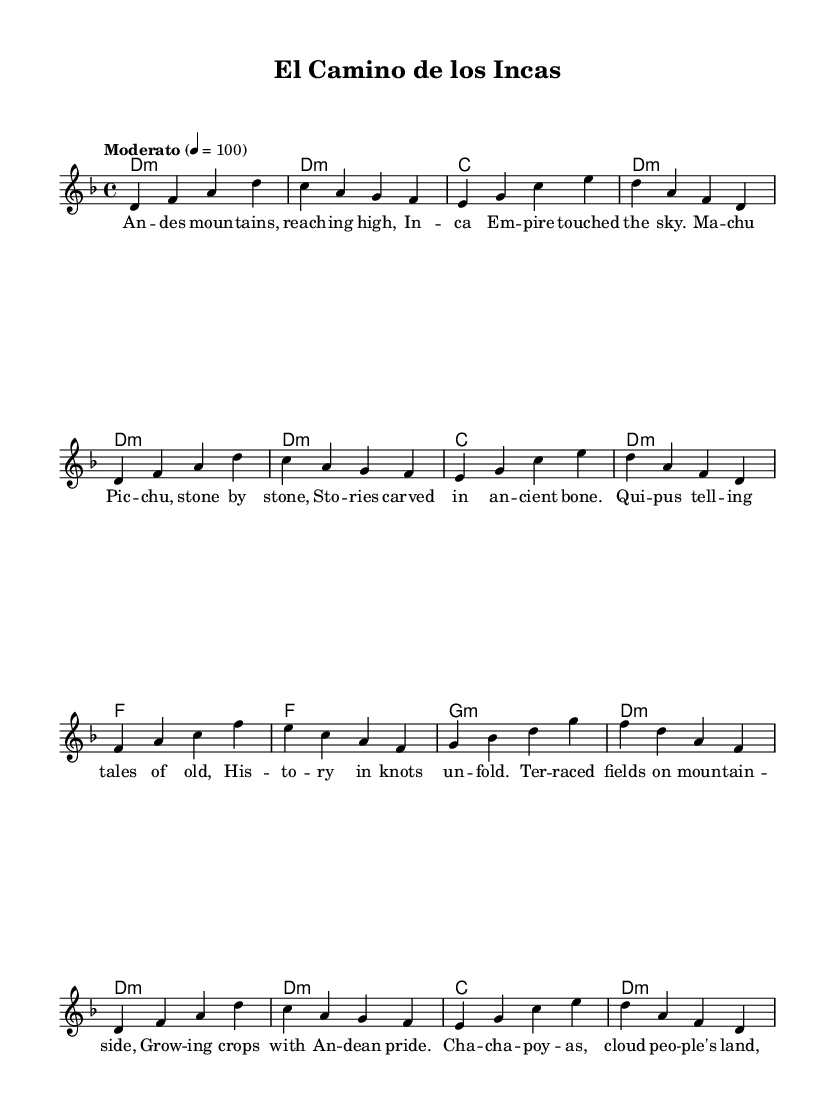What is the key signature of this music? The key signature is indicated at the beginning of the piece. It shows two flats, which corresponds to D minor.
Answer: D minor What is the time signature of this music? The time signature is indicated at the beginning of the piece as a fraction. It shows a 4 on the top and a 4 on the bottom, which denotes four beats per measure.
Answer: 4/4 What tempo marking is provided? The tempo marking is written in Italian above the staff, indicating the speed of the music. It states "Moderato" along with a metronome marking of 100.
Answer: Moderato What is the title of the piece? The title of the piece is displayed prominently at the top of the sheet music, indicating the theme of the composition. The title is "El Camino de los Incas".
Answer: El Camino de los Incas How many verses are in the lyrics? The lyrics consist of multiple lines grouped into stanzas. Counting the lines of lyrics indicates there are four stanzas, each with different lines.
Answer: Four What historical culture does the song reference? The lyrics refer to the "Inca Empire" and discuss specific aspects like Machu Picchu, which is a significant site within ancient Incan culture.
Answer: Inca Empire What musical form is represented in the structure of this song? The structure of the music includes a melody that repeats the same chord changes and uses a clear lyrical pattern which indicates it likely follows a strophic form commonly found in folk songs.
Answer: Strophic form 